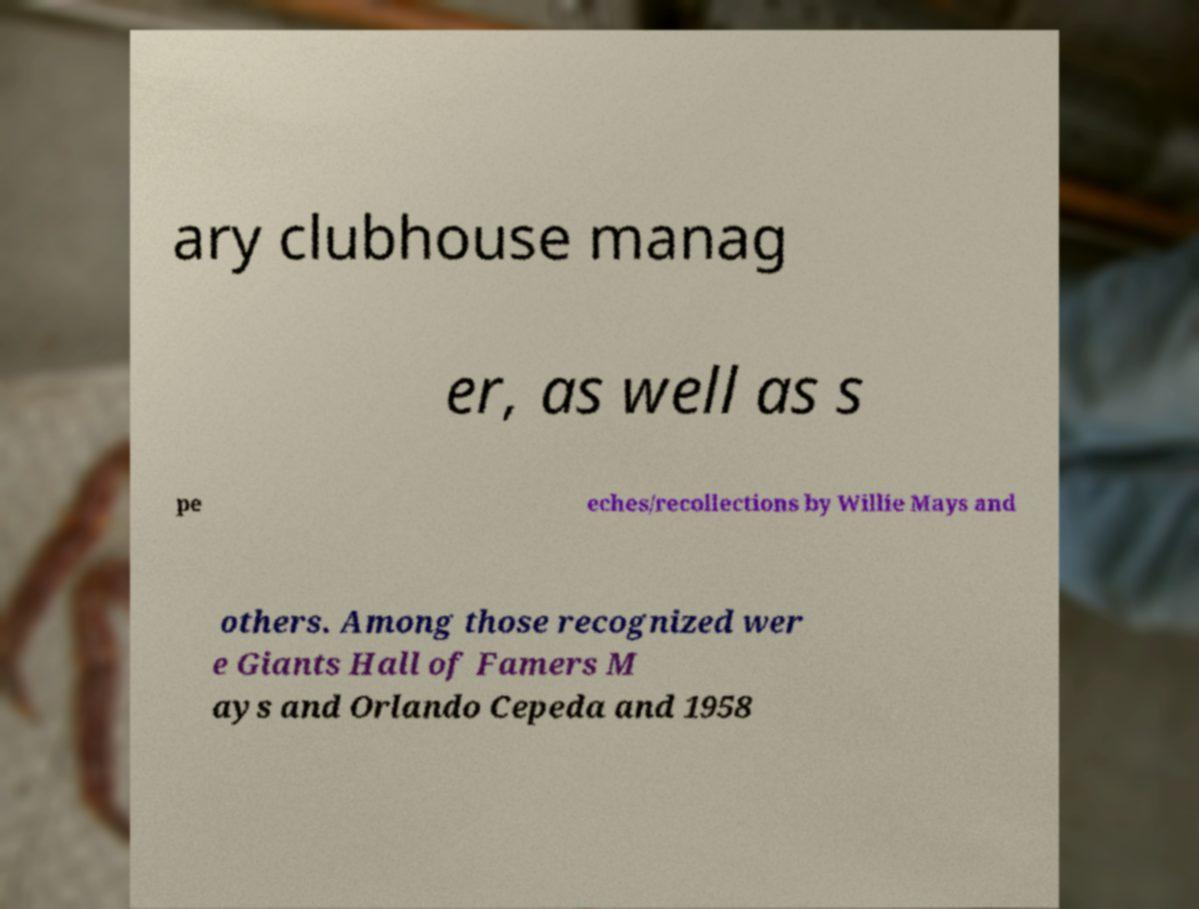Could you assist in decoding the text presented in this image and type it out clearly? ary clubhouse manag er, as well as s pe eches/recollections by Willie Mays and others. Among those recognized wer e Giants Hall of Famers M ays and Orlando Cepeda and 1958 